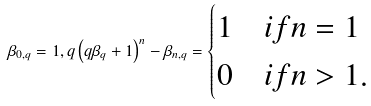<formula> <loc_0><loc_0><loc_500><loc_500>\beta _ { 0 , q } = 1 , q \left ( q \beta _ { q } + 1 \right ) ^ { n } - \beta _ { n , q } = \begin{cases} 1 & i f n = 1 \\ 0 & i f n > 1 . \end{cases}</formula> 